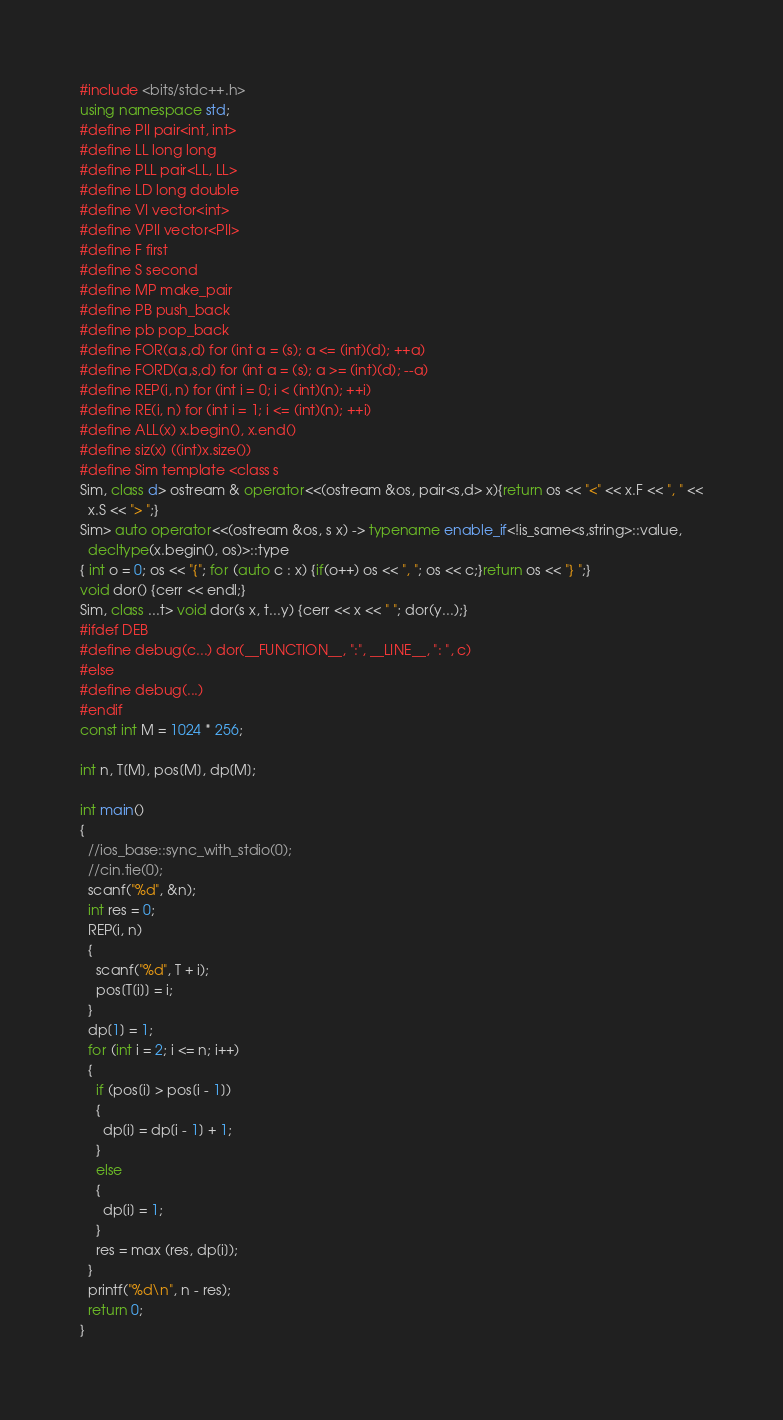Convert code to text. <code><loc_0><loc_0><loc_500><loc_500><_C++_>#include <bits/stdc++.h>
using namespace std;
#define PII pair<int, int>
#define LL long long
#define PLL pair<LL, LL>
#define LD long double
#define VI vector<int>
#define VPII vector<PII>
#define F first
#define S second
#define MP make_pair
#define PB push_back
#define pb pop_back
#define FOR(a,s,d) for (int a = (s); a <= (int)(d); ++a)
#define FORD(a,s,d) for (int a = (s); a >= (int)(d); --a)
#define REP(i, n) for (int i = 0; i < (int)(n); ++i)
#define RE(i, n) for (int i = 1; i <= (int)(n); ++i)
#define ALL(x) x.begin(), x.end()
#define siz(x) ((int)x.size())
#define Sim template <class s
Sim, class d> ostream & operator<<(ostream &os, pair<s,d> x){return os << "<" << x.F << ", " <<
  x.S << "> ";}
Sim> auto operator<<(ostream &os, s x) -> typename enable_if<!is_same<s,string>::value,
  decltype(x.begin(), os)>::type
{ int o = 0; os << "{"; for (auto c : x) {if(o++) os << ", "; os << c;}return os << "} ";}
void dor() {cerr << endl;}
Sim, class ...t> void dor(s x, t...y) {cerr << x << " "; dor(y...);}
#ifdef DEB
#define debug(c...) dor(__FUNCTION__, ":", __LINE__, ": ", c)
#else
#define debug(...)
#endif
const int M = 1024 * 256;

int n, T[M], pos[M], dp[M];

int main()
{
  //ios_base::sync_with_stdio(0);
  //cin.tie(0);
  scanf("%d", &n);
  int res = 0;
  REP(i, n)
  {
    scanf("%d", T + i);
    pos[T[i]] = i;
  }
  dp[1] = 1;
  for (int i = 2; i <= n; i++)
  {
    if (pos[i] > pos[i - 1])
    {
      dp[i] = dp[i - 1] + 1;
    }
    else
    {
      dp[i] = 1;
    }
    res = max (res, dp[i]);
  }
  printf("%d\n", n - res);
  return 0;
}</code> 